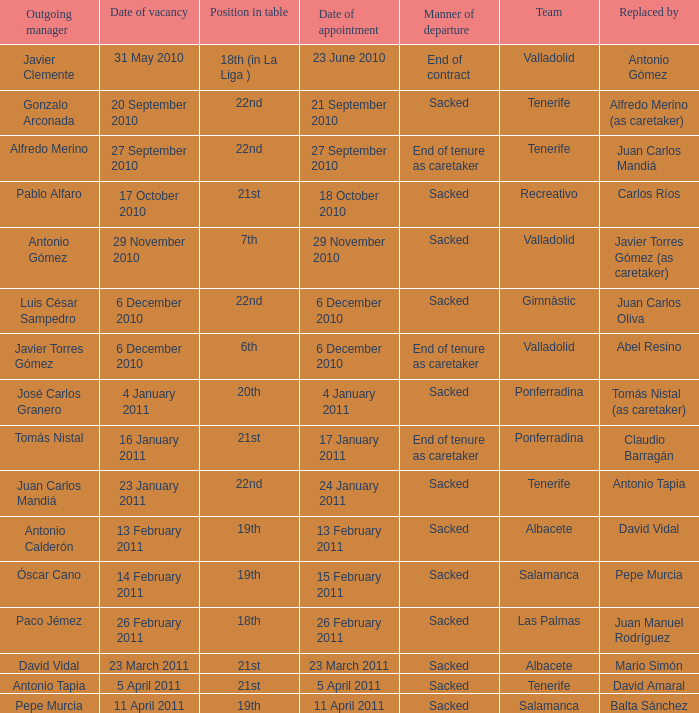What was the manner of departure for the appointment date of 21 september 2010 Sacked. 